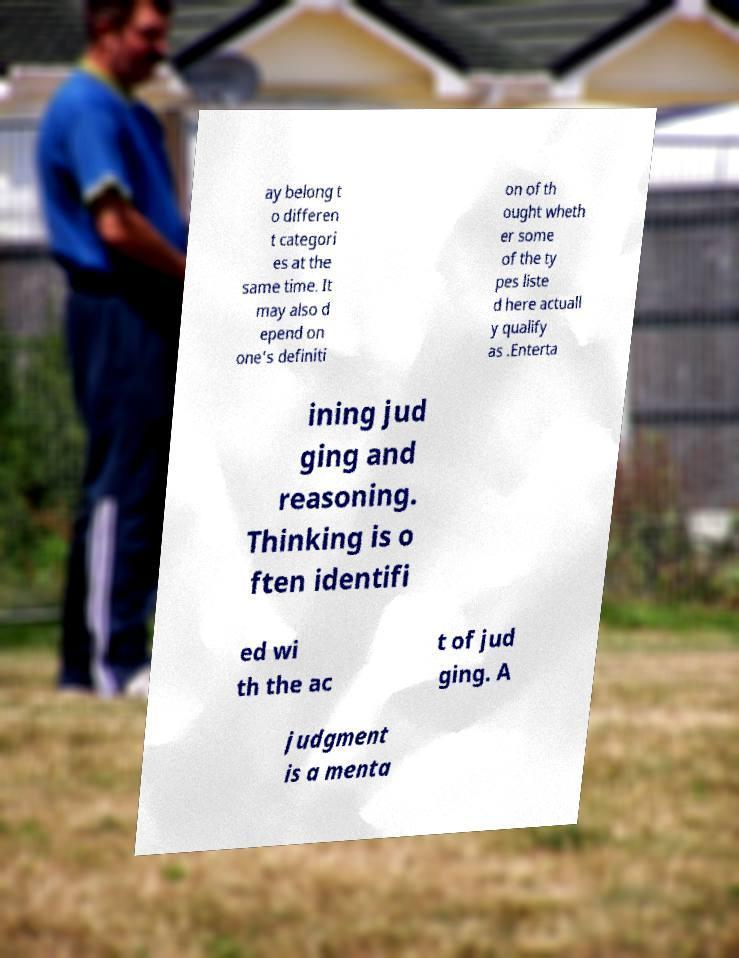What messages or text are displayed in this image? I need them in a readable, typed format. ay belong t o differen t categori es at the same time. It may also d epend on one's definiti on of th ought wheth er some of the ty pes liste d here actuall y qualify as .Enterta ining jud ging and reasoning. Thinking is o ften identifi ed wi th the ac t of jud ging. A judgment is a menta 